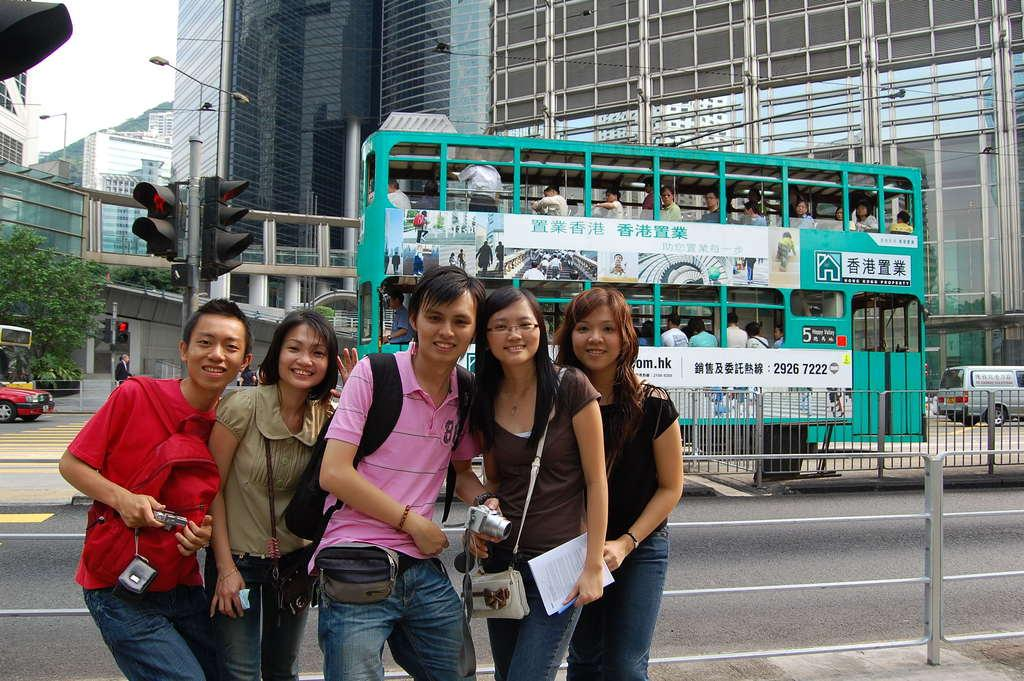<image>
Render a clear and concise summary of the photo. Double decker bus number 5 is a bright teal color. 